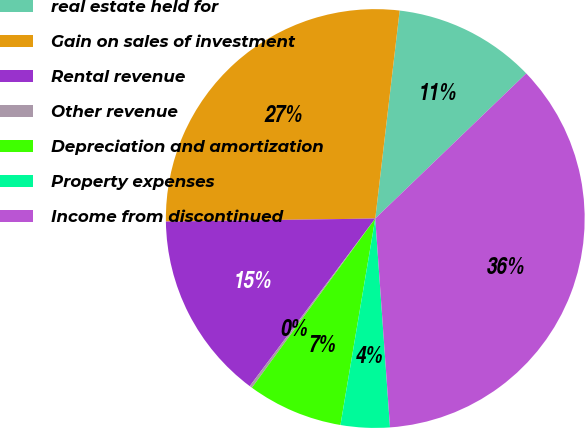Convert chart to OTSL. <chart><loc_0><loc_0><loc_500><loc_500><pie_chart><fcel>real estate held for<fcel>Gain on sales of investment<fcel>Rental revenue<fcel>Other revenue<fcel>Depreciation and amortization<fcel>Property expenses<fcel>Income from discontinued<nl><fcel>10.96%<fcel>27.09%<fcel>14.54%<fcel>0.2%<fcel>7.37%<fcel>3.78%<fcel>36.06%<nl></chart> 